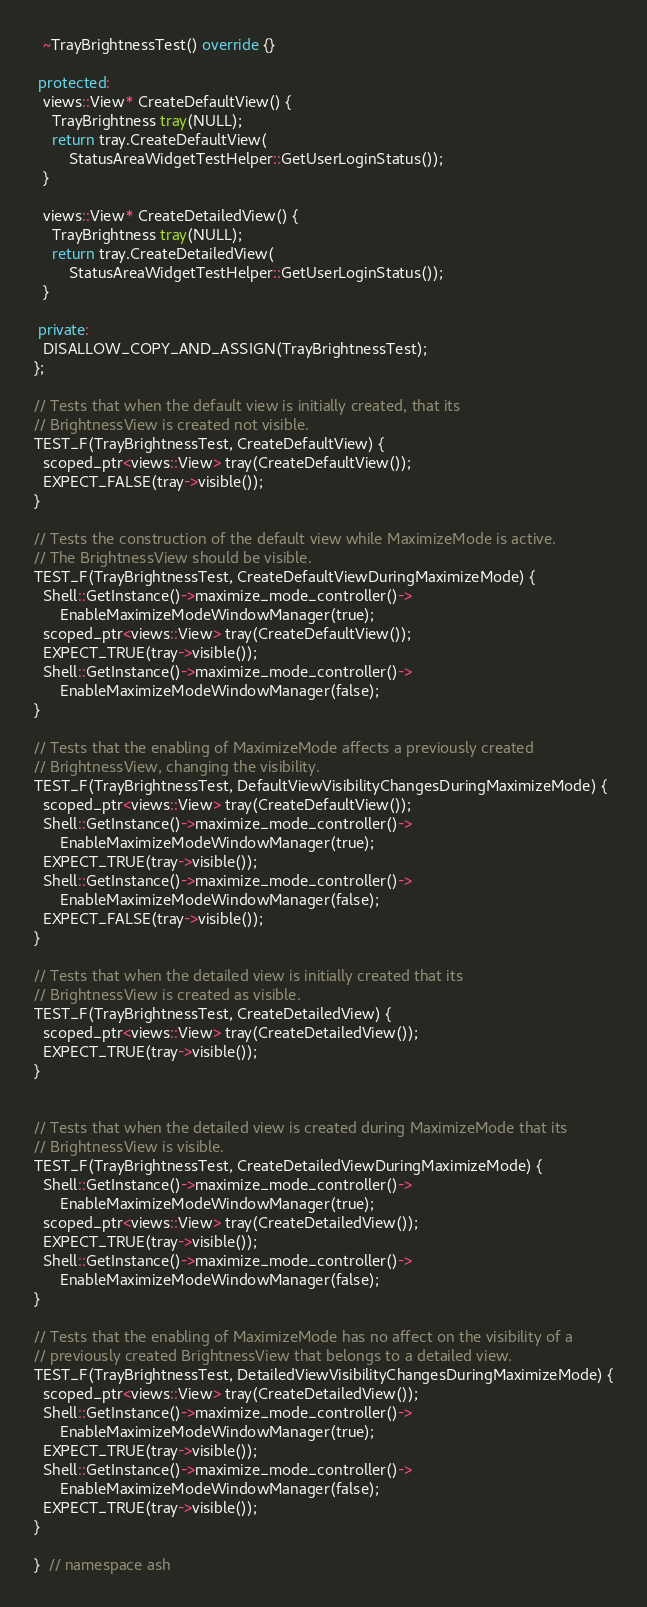Convert code to text. <code><loc_0><loc_0><loc_500><loc_500><_C++_>  ~TrayBrightnessTest() override {}

 protected:
  views::View* CreateDefaultView() {
    TrayBrightness tray(NULL);
    return tray.CreateDefaultView(
        StatusAreaWidgetTestHelper::GetUserLoginStatus());
  }

  views::View* CreateDetailedView() {
    TrayBrightness tray(NULL);
    return tray.CreateDetailedView(
        StatusAreaWidgetTestHelper::GetUserLoginStatus());
  }

 private:
  DISALLOW_COPY_AND_ASSIGN(TrayBrightnessTest);
};

// Tests that when the default view is initially created, that its
// BrightnessView is created not visible.
TEST_F(TrayBrightnessTest, CreateDefaultView) {
  scoped_ptr<views::View> tray(CreateDefaultView());
  EXPECT_FALSE(tray->visible());
}

// Tests the construction of the default view while MaximizeMode is active.
// The BrightnessView should be visible.
TEST_F(TrayBrightnessTest, CreateDefaultViewDuringMaximizeMode) {
  Shell::GetInstance()->maximize_mode_controller()->
      EnableMaximizeModeWindowManager(true);
  scoped_ptr<views::View> tray(CreateDefaultView());
  EXPECT_TRUE(tray->visible());
  Shell::GetInstance()->maximize_mode_controller()->
      EnableMaximizeModeWindowManager(false);
}

// Tests that the enabling of MaximizeMode affects a previously created
// BrightnessView, changing the visibility.
TEST_F(TrayBrightnessTest, DefaultViewVisibilityChangesDuringMaximizeMode) {
  scoped_ptr<views::View> tray(CreateDefaultView());
  Shell::GetInstance()->maximize_mode_controller()->
      EnableMaximizeModeWindowManager(true);
  EXPECT_TRUE(tray->visible());
  Shell::GetInstance()->maximize_mode_controller()->
      EnableMaximizeModeWindowManager(false);
  EXPECT_FALSE(tray->visible());
}

// Tests that when the detailed view is initially created that its
// BrightnessView is created as visible.
TEST_F(TrayBrightnessTest, CreateDetailedView) {
  scoped_ptr<views::View> tray(CreateDetailedView());
  EXPECT_TRUE(tray->visible());
}


// Tests that when the detailed view is created during MaximizeMode that its
// BrightnessView is visible.
TEST_F(TrayBrightnessTest, CreateDetailedViewDuringMaximizeMode) {
  Shell::GetInstance()->maximize_mode_controller()->
      EnableMaximizeModeWindowManager(true);
  scoped_ptr<views::View> tray(CreateDetailedView());
  EXPECT_TRUE(tray->visible());
  Shell::GetInstance()->maximize_mode_controller()->
      EnableMaximizeModeWindowManager(false);
}

// Tests that the enabling of MaximizeMode has no affect on the visibility of a
// previously created BrightnessView that belongs to a detailed view.
TEST_F(TrayBrightnessTest, DetailedViewVisibilityChangesDuringMaximizeMode) {
  scoped_ptr<views::View> tray(CreateDetailedView());
  Shell::GetInstance()->maximize_mode_controller()->
      EnableMaximizeModeWindowManager(true);
  EXPECT_TRUE(tray->visible());
  Shell::GetInstance()->maximize_mode_controller()->
      EnableMaximizeModeWindowManager(false);
  EXPECT_TRUE(tray->visible());
}

}  // namespace ash

</code> 